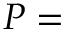<formula> <loc_0><loc_0><loc_500><loc_500>P =</formula> 